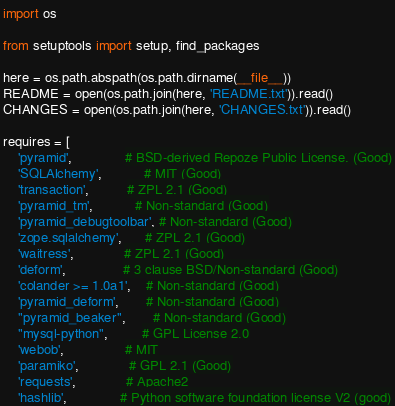Convert code to text. <code><loc_0><loc_0><loc_500><loc_500><_Python_>import os

from setuptools import setup, find_packages

here = os.path.abspath(os.path.dirname(__file__))
README = open(os.path.join(here, 'README.txt')).read()
CHANGES = open(os.path.join(here, 'CHANGES.txt')).read()

requires = [
    'pyramid',              # BSD-derived Repoze Public License. (Good)
    'SQLAlchemy',           # MIT (Good)
    'transaction',          # ZPL 2.1 (Good)
    'pyramid_tm',           # Non-standard (Good)
    'pyramid_debugtoolbar', # Non-standard (Good)
    'zope.sqlalchemy',      # ZPL 2.1 (Good)
    'waitress',             # ZPL 2.1 (Good)
    'deform',               # 3 clause BSD/Non-standard (Good)
    'colander >= 1.0a1',    # Non-standard (Good)
    'pyramid_deform',       # Non-standard (Good)
    "pyramid_beaker",       # Non-standard (Good)
    "mysql-python",         # GPL License 2.0
    'webob',                # MIT
    'paramiko',             # GPL 2.1 (Good)
    'requests',             # Apache2
    'hashlib',              # Python software foundation license V2 (good)</code> 